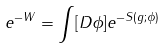<formula> <loc_0><loc_0><loc_500><loc_500>e ^ { - W } = \int [ D \phi ] e ^ { - S ( g ; \phi ) }</formula> 